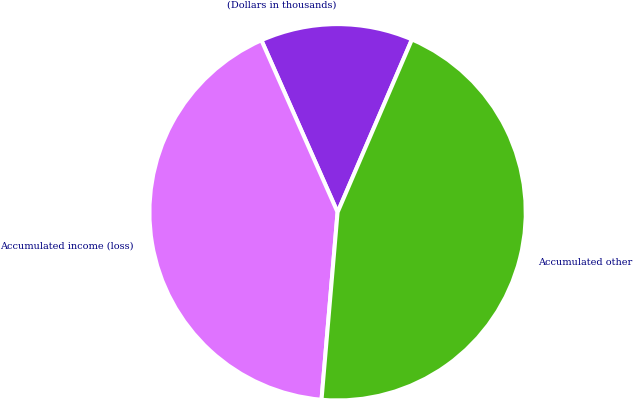Convert chart. <chart><loc_0><loc_0><loc_500><loc_500><pie_chart><fcel>(Dollars in thousands)<fcel>Accumulated income (loss)<fcel>Accumulated other<nl><fcel>13.1%<fcel>42.0%<fcel>44.89%<nl></chart> 